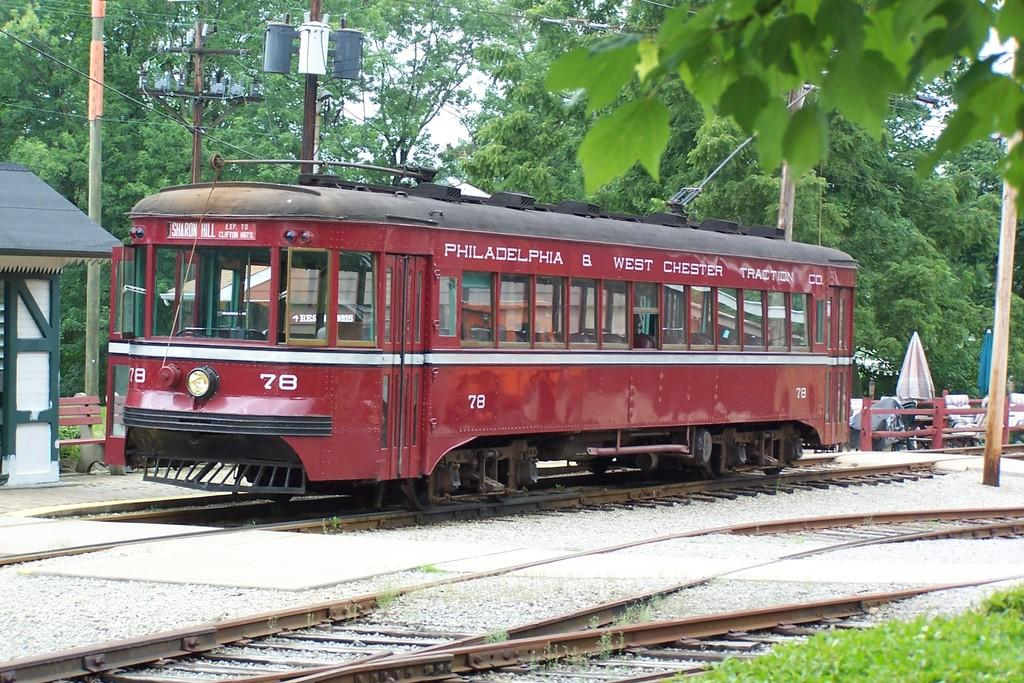What is the main subject of the image? There is a train in the image. Where is the train located? The train is on a railway track. What else can be seen in the image besides the train? There is a fence, umbrellas, poles, a bench, a shade, trees, grass, and the sky visible in the image. What type of appliance is being used by the train in the image? There is no appliance being used by the train in the image. The train is simply on a railway track, and no appliances are mentioned or visible in the image. 